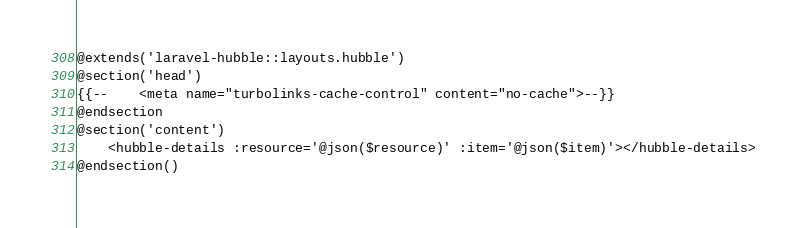Convert code to text. <code><loc_0><loc_0><loc_500><loc_500><_PHP_>@extends('laravel-hubble::layouts.hubble')
@section('head')
{{--    <meta name="turbolinks-cache-control" content="no-cache">--}}
@endsection
@section('content')
    <hubble-details :resource='@json($resource)' :item='@json($item)'></hubble-details>
@endsection()
</code> 